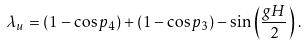Convert formula to latex. <formula><loc_0><loc_0><loc_500><loc_500>\lambda _ { u } = ( 1 - \cos p _ { 4 } ) + ( 1 - \cos p _ { 3 } ) - \sin \left ( \frac { g H } { 2 } \right ) \, .</formula> 